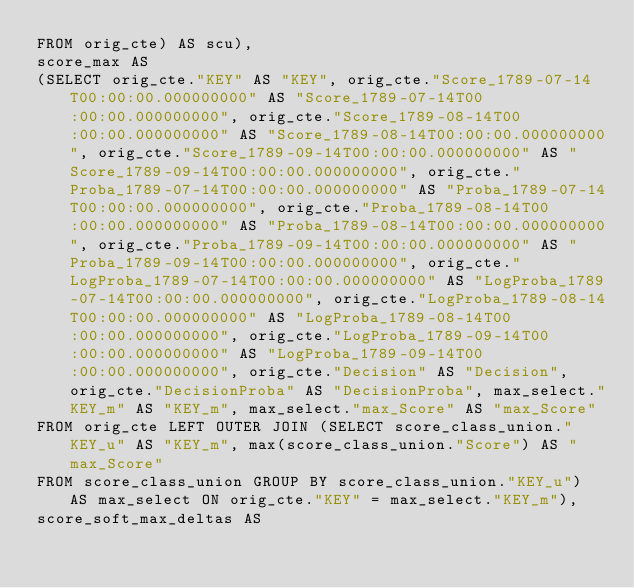Convert code to text. <code><loc_0><loc_0><loc_500><loc_500><_SQL_>FROM orig_cte) AS scu), 
score_max AS 
(SELECT orig_cte."KEY" AS "KEY", orig_cte."Score_1789-07-14T00:00:00.000000000" AS "Score_1789-07-14T00:00:00.000000000", orig_cte."Score_1789-08-14T00:00:00.000000000" AS "Score_1789-08-14T00:00:00.000000000", orig_cte."Score_1789-09-14T00:00:00.000000000" AS "Score_1789-09-14T00:00:00.000000000", orig_cte."Proba_1789-07-14T00:00:00.000000000" AS "Proba_1789-07-14T00:00:00.000000000", orig_cte."Proba_1789-08-14T00:00:00.000000000" AS "Proba_1789-08-14T00:00:00.000000000", orig_cte."Proba_1789-09-14T00:00:00.000000000" AS "Proba_1789-09-14T00:00:00.000000000", orig_cte."LogProba_1789-07-14T00:00:00.000000000" AS "LogProba_1789-07-14T00:00:00.000000000", orig_cte."LogProba_1789-08-14T00:00:00.000000000" AS "LogProba_1789-08-14T00:00:00.000000000", orig_cte."LogProba_1789-09-14T00:00:00.000000000" AS "LogProba_1789-09-14T00:00:00.000000000", orig_cte."Decision" AS "Decision", orig_cte."DecisionProba" AS "DecisionProba", max_select."KEY_m" AS "KEY_m", max_select."max_Score" AS "max_Score" 
FROM orig_cte LEFT OUTER JOIN (SELECT score_class_union."KEY_u" AS "KEY_m", max(score_class_union."Score") AS "max_Score" 
FROM score_class_union GROUP BY score_class_union."KEY_u") AS max_select ON orig_cte."KEY" = max_select."KEY_m"), 
score_soft_max_deltas AS </code> 